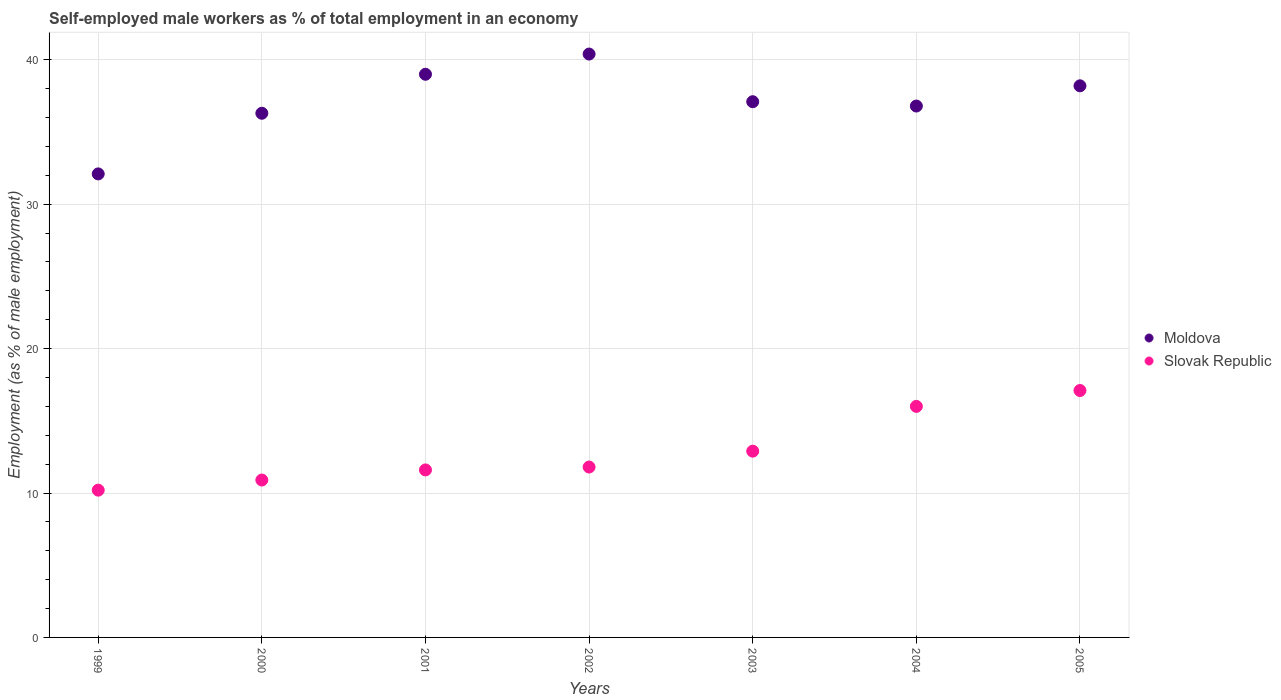How many different coloured dotlines are there?
Offer a very short reply. 2. What is the percentage of self-employed male workers in Slovak Republic in 2003?
Give a very brief answer. 12.9. Across all years, what is the maximum percentage of self-employed male workers in Slovak Republic?
Ensure brevity in your answer.  17.1. Across all years, what is the minimum percentage of self-employed male workers in Slovak Republic?
Provide a short and direct response. 10.2. In which year was the percentage of self-employed male workers in Moldova minimum?
Provide a short and direct response. 1999. What is the total percentage of self-employed male workers in Slovak Republic in the graph?
Keep it short and to the point. 90.5. What is the difference between the percentage of self-employed male workers in Moldova in 2004 and that in 2005?
Your answer should be compact. -1.4. What is the difference between the percentage of self-employed male workers in Moldova in 2004 and the percentage of self-employed male workers in Slovak Republic in 2000?
Make the answer very short. 25.9. What is the average percentage of self-employed male workers in Slovak Republic per year?
Offer a terse response. 12.93. In the year 2003, what is the difference between the percentage of self-employed male workers in Slovak Republic and percentage of self-employed male workers in Moldova?
Ensure brevity in your answer.  -24.2. In how many years, is the percentage of self-employed male workers in Slovak Republic greater than 12 %?
Your answer should be very brief. 3. What is the ratio of the percentage of self-employed male workers in Moldova in 2002 to that in 2004?
Ensure brevity in your answer.  1.1. Is the percentage of self-employed male workers in Slovak Republic in 2004 less than that in 2005?
Offer a terse response. Yes. Is the difference between the percentage of self-employed male workers in Slovak Republic in 2000 and 2002 greater than the difference between the percentage of self-employed male workers in Moldova in 2000 and 2002?
Your answer should be very brief. Yes. What is the difference between the highest and the second highest percentage of self-employed male workers in Moldova?
Provide a short and direct response. 1.4. What is the difference between the highest and the lowest percentage of self-employed male workers in Slovak Republic?
Make the answer very short. 6.9. In how many years, is the percentage of self-employed male workers in Slovak Republic greater than the average percentage of self-employed male workers in Slovak Republic taken over all years?
Offer a terse response. 2. Is the sum of the percentage of self-employed male workers in Moldova in 2000 and 2001 greater than the maximum percentage of self-employed male workers in Slovak Republic across all years?
Offer a very short reply. Yes. Does the percentage of self-employed male workers in Slovak Republic monotonically increase over the years?
Make the answer very short. Yes. Is the percentage of self-employed male workers in Moldova strictly greater than the percentage of self-employed male workers in Slovak Republic over the years?
Provide a succinct answer. Yes. Does the graph contain any zero values?
Give a very brief answer. No. Does the graph contain grids?
Offer a terse response. Yes. Where does the legend appear in the graph?
Make the answer very short. Center right. How many legend labels are there?
Your response must be concise. 2. How are the legend labels stacked?
Your answer should be compact. Vertical. What is the title of the graph?
Give a very brief answer. Self-employed male workers as % of total employment in an economy. What is the label or title of the X-axis?
Make the answer very short. Years. What is the label or title of the Y-axis?
Give a very brief answer. Employment (as % of male employment). What is the Employment (as % of male employment) in Moldova in 1999?
Ensure brevity in your answer.  32.1. What is the Employment (as % of male employment) of Slovak Republic in 1999?
Your answer should be very brief. 10.2. What is the Employment (as % of male employment) of Moldova in 2000?
Your answer should be compact. 36.3. What is the Employment (as % of male employment) of Slovak Republic in 2000?
Offer a terse response. 10.9. What is the Employment (as % of male employment) of Moldova in 2001?
Keep it short and to the point. 39. What is the Employment (as % of male employment) of Slovak Republic in 2001?
Offer a terse response. 11.6. What is the Employment (as % of male employment) of Moldova in 2002?
Give a very brief answer. 40.4. What is the Employment (as % of male employment) in Slovak Republic in 2002?
Provide a succinct answer. 11.8. What is the Employment (as % of male employment) in Moldova in 2003?
Keep it short and to the point. 37.1. What is the Employment (as % of male employment) in Slovak Republic in 2003?
Offer a very short reply. 12.9. What is the Employment (as % of male employment) in Moldova in 2004?
Make the answer very short. 36.8. What is the Employment (as % of male employment) of Slovak Republic in 2004?
Your answer should be compact. 16. What is the Employment (as % of male employment) in Moldova in 2005?
Your answer should be very brief. 38.2. What is the Employment (as % of male employment) of Slovak Republic in 2005?
Give a very brief answer. 17.1. Across all years, what is the maximum Employment (as % of male employment) in Moldova?
Make the answer very short. 40.4. Across all years, what is the maximum Employment (as % of male employment) in Slovak Republic?
Make the answer very short. 17.1. Across all years, what is the minimum Employment (as % of male employment) in Moldova?
Provide a short and direct response. 32.1. Across all years, what is the minimum Employment (as % of male employment) of Slovak Republic?
Ensure brevity in your answer.  10.2. What is the total Employment (as % of male employment) in Moldova in the graph?
Provide a short and direct response. 259.9. What is the total Employment (as % of male employment) of Slovak Republic in the graph?
Offer a terse response. 90.5. What is the difference between the Employment (as % of male employment) in Slovak Republic in 1999 and that in 2001?
Your response must be concise. -1.4. What is the difference between the Employment (as % of male employment) in Moldova in 1999 and that in 2003?
Make the answer very short. -5. What is the difference between the Employment (as % of male employment) of Slovak Republic in 1999 and that in 2003?
Make the answer very short. -2.7. What is the difference between the Employment (as % of male employment) in Moldova in 1999 and that in 2005?
Offer a terse response. -6.1. What is the difference between the Employment (as % of male employment) in Moldova in 2000 and that in 2001?
Make the answer very short. -2.7. What is the difference between the Employment (as % of male employment) of Slovak Republic in 2000 and that in 2003?
Offer a terse response. -2. What is the difference between the Employment (as % of male employment) of Moldova in 2000 and that in 2004?
Provide a succinct answer. -0.5. What is the difference between the Employment (as % of male employment) of Slovak Republic in 2000 and that in 2004?
Provide a succinct answer. -5.1. What is the difference between the Employment (as % of male employment) of Slovak Republic in 2000 and that in 2005?
Your answer should be very brief. -6.2. What is the difference between the Employment (as % of male employment) in Moldova in 2001 and that in 2002?
Ensure brevity in your answer.  -1.4. What is the difference between the Employment (as % of male employment) of Slovak Republic in 2001 and that in 2003?
Your answer should be very brief. -1.3. What is the difference between the Employment (as % of male employment) in Slovak Republic in 2001 and that in 2004?
Your response must be concise. -4.4. What is the difference between the Employment (as % of male employment) in Slovak Republic in 2001 and that in 2005?
Keep it short and to the point. -5.5. What is the difference between the Employment (as % of male employment) of Slovak Republic in 2002 and that in 2003?
Provide a succinct answer. -1.1. What is the difference between the Employment (as % of male employment) of Moldova in 2002 and that in 2004?
Give a very brief answer. 3.6. What is the difference between the Employment (as % of male employment) in Slovak Republic in 2002 and that in 2004?
Offer a very short reply. -4.2. What is the difference between the Employment (as % of male employment) of Moldova in 2002 and that in 2005?
Your answer should be compact. 2.2. What is the difference between the Employment (as % of male employment) of Slovak Republic in 2002 and that in 2005?
Your answer should be very brief. -5.3. What is the difference between the Employment (as % of male employment) in Moldova in 2003 and that in 2004?
Give a very brief answer. 0.3. What is the difference between the Employment (as % of male employment) in Moldova in 2003 and that in 2005?
Make the answer very short. -1.1. What is the difference between the Employment (as % of male employment) in Slovak Republic in 2004 and that in 2005?
Your response must be concise. -1.1. What is the difference between the Employment (as % of male employment) of Moldova in 1999 and the Employment (as % of male employment) of Slovak Republic in 2000?
Your answer should be compact. 21.2. What is the difference between the Employment (as % of male employment) in Moldova in 1999 and the Employment (as % of male employment) in Slovak Republic in 2002?
Provide a short and direct response. 20.3. What is the difference between the Employment (as % of male employment) in Moldova in 2000 and the Employment (as % of male employment) in Slovak Republic in 2001?
Your answer should be compact. 24.7. What is the difference between the Employment (as % of male employment) in Moldova in 2000 and the Employment (as % of male employment) in Slovak Republic in 2002?
Your answer should be compact. 24.5. What is the difference between the Employment (as % of male employment) in Moldova in 2000 and the Employment (as % of male employment) in Slovak Republic in 2003?
Ensure brevity in your answer.  23.4. What is the difference between the Employment (as % of male employment) of Moldova in 2000 and the Employment (as % of male employment) of Slovak Republic in 2004?
Your response must be concise. 20.3. What is the difference between the Employment (as % of male employment) of Moldova in 2001 and the Employment (as % of male employment) of Slovak Republic in 2002?
Make the answer very short. 27.2. What is the difference between the Employment (as % of male employment) of Moldova in 2001 and the Employment (as % of male employment) of Slovak Republic in 2003?
Your response must be concise. 26.1. What is the difference between the Employment (as % of male employment) of Moldova in 2001 and the Employment (as % of male employment) of Slovak Republic in 2004?
Provide a short and direct response. 23. What is the difference between the Employment (as % of male employment) in Moldova in 2001 and the Employment (as % of male employment) in Slovak Republic in 2005?
Make the answer very short. 21.9. What is the difference between the Employment (as % of male employment) of Moldova in 2002 and the Employment (as % of male employment) of Slovak Republic in 2003?
Make the answer very short. 27.5. What is the difference between the Employment (as % of male employment) of Moldova in 2002 and the Employment (as % of male employment) of Slovak Republic in 2004?
Your response must be concise. 24.4. What is the difference between the Employment (as % of male employment) of Moldova in 2002 and the Employment (as % of male employment) of Slovak Republic in 2005?
Ensure brevity in your answer.  23.3. What is the difference between the Employment (as % of male employment) of Moldova in 2003 and the Employment (as % of male employment) of Slovak Republic in 2004?
Provide a short and direct response. 21.1. What is the difference between the Employment (as % of male employment) in Moldova in 2004 and the Employment (as % of male employment) in Slovak Republic in 2005?
Your answer should be compact. 19.7. What is the average Employment (as % of male employment) of Moldova per year?
Give a very brief answer. 37.13. What is the average Employment (as % of male employment) of Slovak Republic per year?
Offer a very short reply. 12.93. In the year 1999, what is the difference between the Employment (as % of male employment) in Moldova and Employment (as % of male employment) in Slovak Republic?
Offer a terse response. 21.9. In the year 2000, what is the difference between the Employment (as % of male employment) in Moldova and Employment (as % of male employment) in Slovak Republic?
Your answer should be very brief. 25.4. In the year 2001, what is the difference between the Employment (as % of male employment) of Moldova and Employment (as % of male employment) of Slovak Republic?
Your response must be concise. 27.4. In the year 2002, what is the difference between the Employment (as % of male employment) of Moldova and Employment (as % of male employment) of Slovak Republic?
Your answer should be very brief. 28.6. In the year 2003, what is the difference between the Employment (as % of male employment) of Moldova and Employment (as % of male employment) of Slovak Republic?
Ensure brevity in your answer.  24.2. In the year 2004, what is the difference between the Employment (as % of male employment) in Moldova and Employment (as % of male employment) in Slovak Republic?
Your answer should be compact. 20.8. In the year 2005, what is the difference between the Employment (as % of male employment) of Moldova and Employment (as % of male employment) of Slovak Republic?
Provide a succinct answer. 21.1. What is the ratio of the Employment (as % of male employment) in Moldova in 1999 to that in 2000?
Give a very brief answer. 0.88. What is the ratio of the Employment (as % of male employment) of Slovak Republic in 1999 to that in 2000?
Ensure brevity in your answer.  0.94. What is the ratio of the Employment (as % of male employment) of Moldova in 1999 to that in 2001?
Provide a short and direct response. 0.82. What is the ratio of the Employment (as % of male employment) of Slovak Republic in 1999 to that in 2001?
Provide a succinct answer. 0.88. What is the ratio of the Employment (as % of male employment) in Moldova in 1999 to that in 2002?
Offer a very short reply. 0.79. What is the ratio of the Employment (as % of male employment) of Slovak Republic in 1999 to that in 2002?
Offer a very short reply. 0.86. What is the ratio of the Employment (as % of male employment) of Moldova in 1999 to that in 2003?
Make the answer very short. 0.87. What is the ratio of the Employment (as % of male employment) of Slovak Republic in 1999 to that in 2003?
Provide a succinct answer. 0.79. What is the ratio of the Employment (as % of male employment) in Moldova in 1999 to that in 2004?
Your answer should be very brief. 0.87. What is the ratio of the Employment (as % of male employment) of Slovak Republic in 1999 to that in 2004?
Your response must be concise. 0.64. What is the ratio of the Employment (as % of male employment) in Moldova in 1999 to that in 2005?
Offer a terse response. 0.84. What is the ratio of the Employment (as % of male employment) in Slovak Republic in 1999 to that in 2005?
Your answer should be very brief. 0.6. What is the ratio of the Employment (as % of male employment) in Moldova in 2000 to that in 2001?
Your response must be concise. 0.93. What is the ratio of the Employment (as % of male employment) of Slovak Republic in 2000 to that in 2001?
Provide a succinct answer. 0.94. What is the ratio of the Employment (as % of male employment) in Moldova in 2000 to that in 2002?
Make the answer very short. 0.9. What is the ratio of the Employment (as % of male employment) of Slovak Republic in 2000 to that in 2002?
Give a very brief answer. 0.92. What is the ratio of the Employment (as % of male employment) in Moldova in 2000 to that in 2003?
Your answer should be compact. 0.98. What is the ratio of the Employment (as % of male employment) in Slovak Republic in 2000 to that in 2003?
Provide a short and direct response. 0.84. What is the ratio of the Employment (as % of male employment) of Moldova in 2000 to that in 2004?
Make the answer very short. 0.99. What is the ratio of the Employment (as % of male employment) of Slovak Republic in 2000 to that in 2004?
Ensure brevity in your answer.  0.68. What is the ratio of the Employment (as % of male employment) of Moldova in 2000 to that in 2005?
Offer a terse response. 0.95. What is the ratio of the Employment (as % of male employment) of Slovak Republic in 2000 to that in 2005?
Offer a terse response. 0.64. What is the ratio of the Employment (as % of male employment) in Moldova in 2001 to that in 2002?
Make the answer very short. 0.97. What is the ratio of the Employment (as % of male employment) of Slovak Republic in 2001 to that in 2002?
Your answer should be compact. 0.98. What is the ratio of the Employment (as % of male employment) in Moldova in 2001 to that in 2003?
Provide a short and direct response. 1.05. What is the ratio of the Employment (as % of male employment) of Slovak Republic in 2001 to that in 2003?
Your response must be concise. 0.9. What is the ratio of the Employment (as % of male employment) in Moldova in 2001 to that in 2004?
Your answer should be very brief. 1.06. What is the ratio of the Employment (as % of male employment) of Slovak Republic in 2001 to that in 2004?
Your response must be concise. 0.72. What is the ratio of the Employment (as % of male employment) in Moldova in 2001 to that in 2005?
Keep it short and to the point. 1.02. What is the ratio of the Employment (as % of male employment) in Slovak Republic in 2001 to that in 2005?
Your answer should be compact. 0.68. What is the ratio of the Employment (as % of male employment) in Moldova in 2002 to that in 2003?
Make the answer very short. 1.09. What is the ratio of the Employment (as % of male employment) of Slovak Republic in 2002 to that in 2003?
Keep it short and to the point. 0.91. What is the ratio of the Employment (as % of male employment) in Moldova in 2002 to that in 2004?
Make the answer very short. 1.1. What is the ratio of the Employment (as % of male employment) of Slovak Republic in 2002 to that in 2004?
Your answer should be compact. 0.74. What is the ratio of the Employment (as % of male employment) in Moldova in 2002 to that in 2005?
Provide a short and direct response. 1.06. What is the ratio of the Employment (as % of male employment) in Slovak Republic in 2002 to that in 2005?
Offer a very short reply. 0.69. What is the ratio of the Employment (as % of male employment) in Moldova in 2003 to that in 2004?
Provide a succinct answer. 1.01. What is the ratio of the Employment (as % of male employment) of Slovak Republic in 2003 to that in 2004?
Make the answer very short. 0.81. What is the ratio of the Employment (as % of male employment) in Moldova in 2003 to that in 2005?
Offer a very short reply. 0.97. What is the ratio of the Employment (as % of male employment) in Slovak Republic in 2003 to that in 2005?
Provide a succinct answer. 0.75. What is the ratio of the Employment (as % of male employment) in Moldova in 2004 to that in 2005?
Offer a very short reply. 0.96. What is the ratio of the Employment (as % of male employment) in Slovak Republic in 2004 to that in 2005?
Offer a terse response. 0.94. 